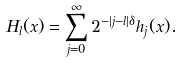Convert formula to latex. <formula><loc_0><loc_0><loc_500><loc_500>H _ { l } ( x ) = \sum _ { j = 0 } ^ { \infty } 2 ^ { - | j - l | \delta } h _ { j } ( x ) .</formula> 